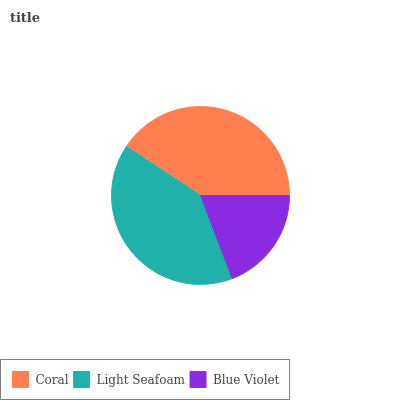Is Blue Violet the minimum?
Answer yes or no. Yes. Is Coral the maximum?
Answer yes or no. Yes. Is Light Seafoam the minimum?
Answer yes or no. No. Is Light Seafoam the maximum?
Answer yes or no. No. Is Coral greater than Light Seafoam?
Answer yes or no. Yes. Is Light Seafoam less than Coral?
Answer yes or no. Yes. Is Light Seafoam greater than Coral?
Answer yes or no. No. Is Coral less than Light Seafoam?
Answer yes or no. No. Is Light Seafoam the high median?
Answer yes or no. Yes. Is Light Seafoam the low median?
Answer yes or no. Yes. Is Blue Violet the high median?
Answer yes or no. No. Is Coral the low median?
Answer yes or no. No. 